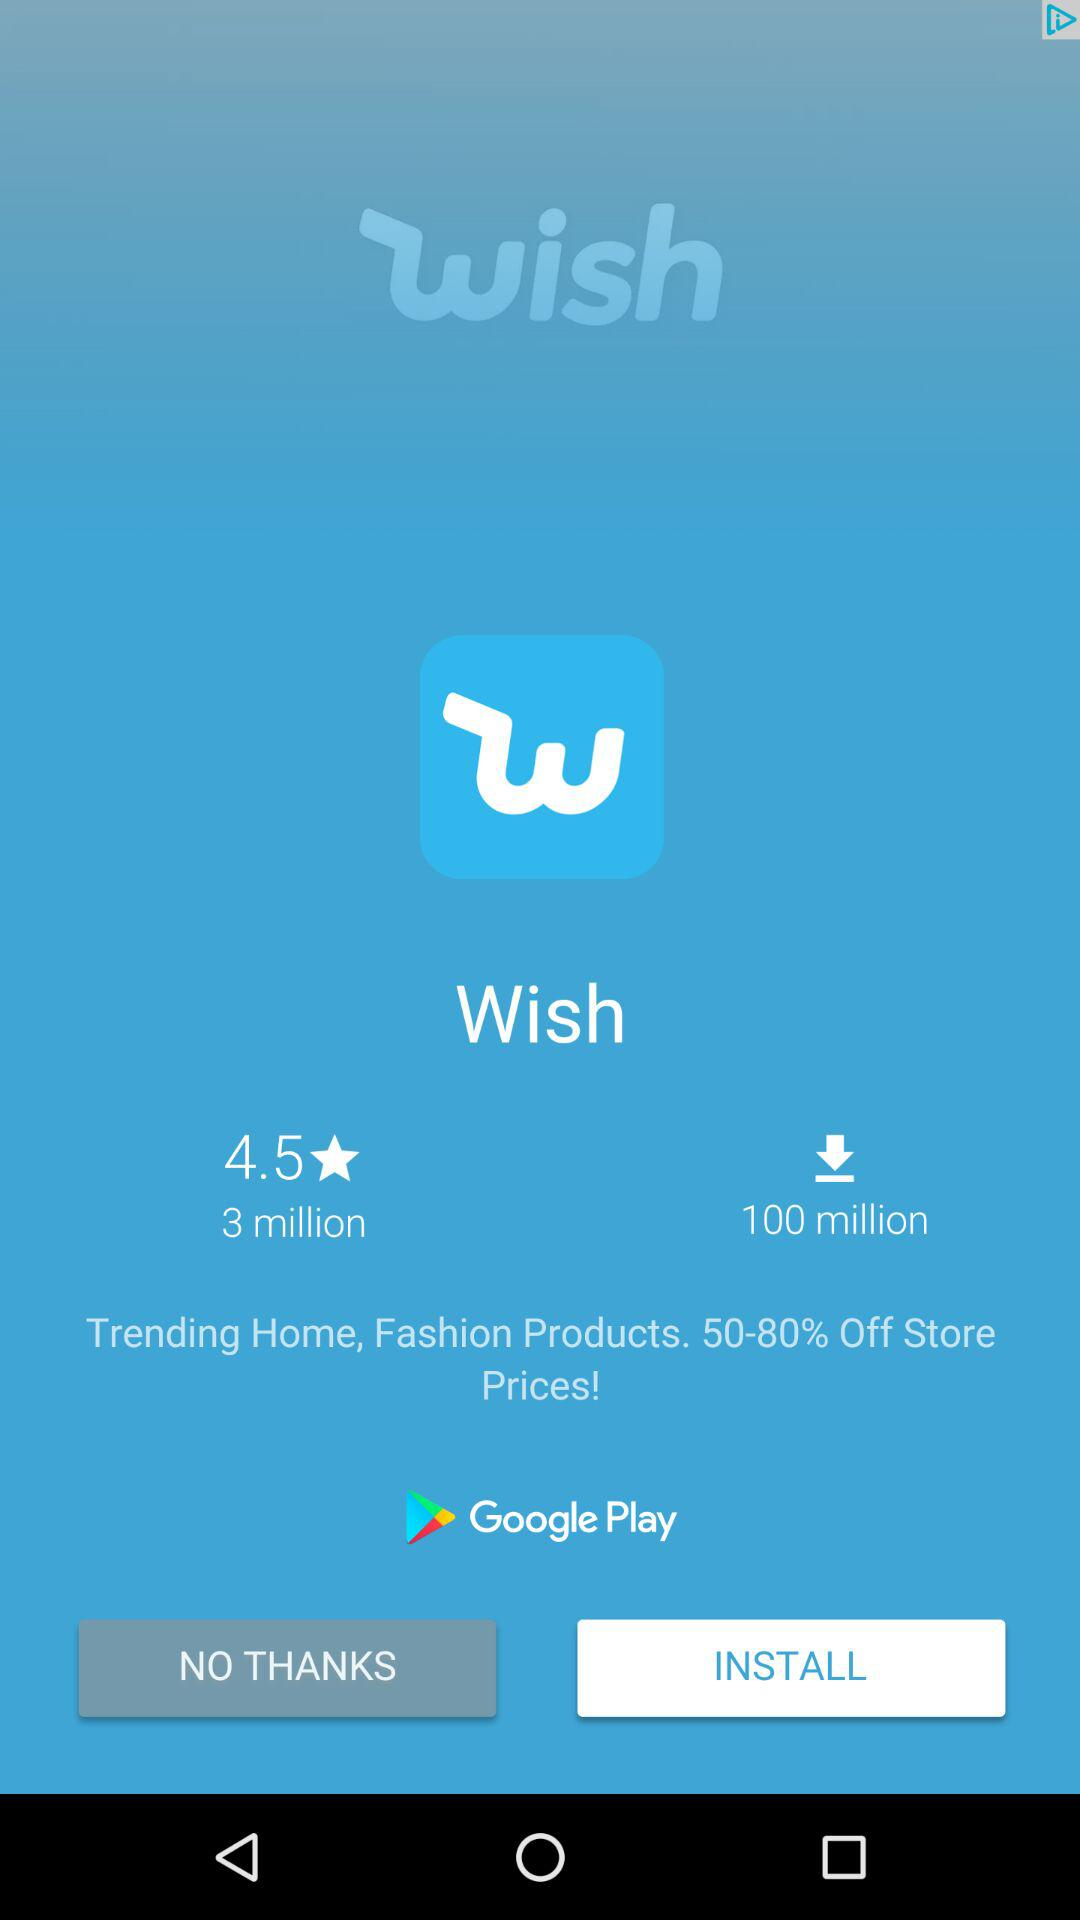How many more downloads does Wish have than reviews?
Answer the question using a single word or phrase. 97 million 